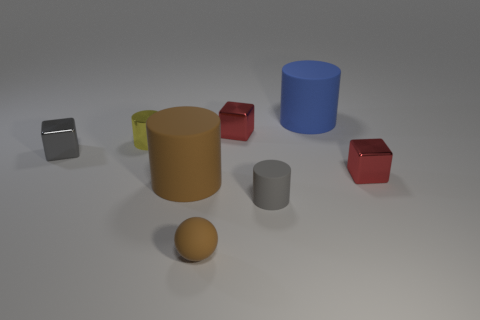Add 1 large rubber cylinders. How many objects exist? 9 Subtract all cubes. How many objects are left? 5 Add 4 small brown matte balls. How many small brown matte balls are left? 5 Add 5 big blue rubber objects. How many big blue rubber objects exist? 6 Subtract 1 gray cylinders. How many objects are left? 7 Subtract all big rubber objects. Subtract all cylinders. How many objects are left? 2 